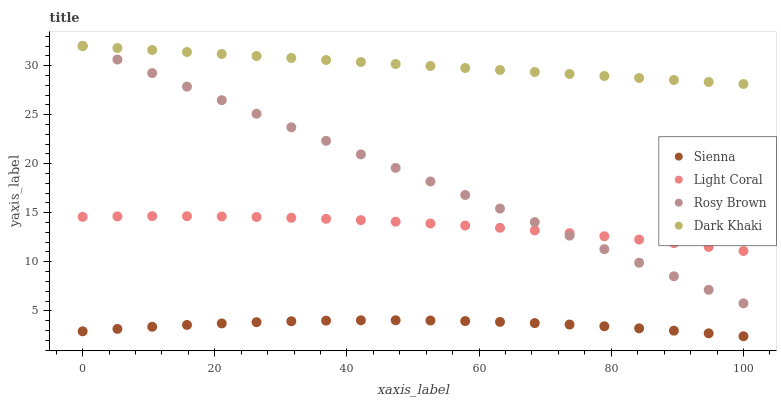Does Sienna have the minimum area under the curve?
Answer yes or no. Yes. Does Dark Khaki have the maximum area under the curve?
Answer yes or no. Yes. Does Light Coral have the minimum area under the curve?
Answer yes or no. No. Does Light Coral have the maximum area under the curve?
Answer yes or no. No. Is Dark Khaki the smoothest?
Answer yes or no. Yes. Is Sienna the roughest?
Answer yes or no. Yes. Is Light Coral the smoothest?
Answer yes or no. No. Is Light Coral the roughest?
Answer yes or no. No. Does Sienna have the lowest value?
Answer yes or no. Yes. Does Light Coral have the lowest value?
Answer yes or no. No. Does Dark Khaki have the highest value?
Answer yes or no. Yes. Does Light Coral have the highest value?
Answer yes or no. No. Is Sienna less than Rosy Brown?
Answer yes or no. Yes. Is Dark Khaki greater than Light Coral?
Answer yes or no. Yes. Does Rosy Brown intersect Light Coral?
Answer yes or no. Yes. Is Rosy Brown less than Light Coral?
Answer yes or no. No. Is Rosy Brown greater than Light Coral?
Answer yes or no. No. Does Sienna intersect Rosy Brown?
Answer yes or no. No. 